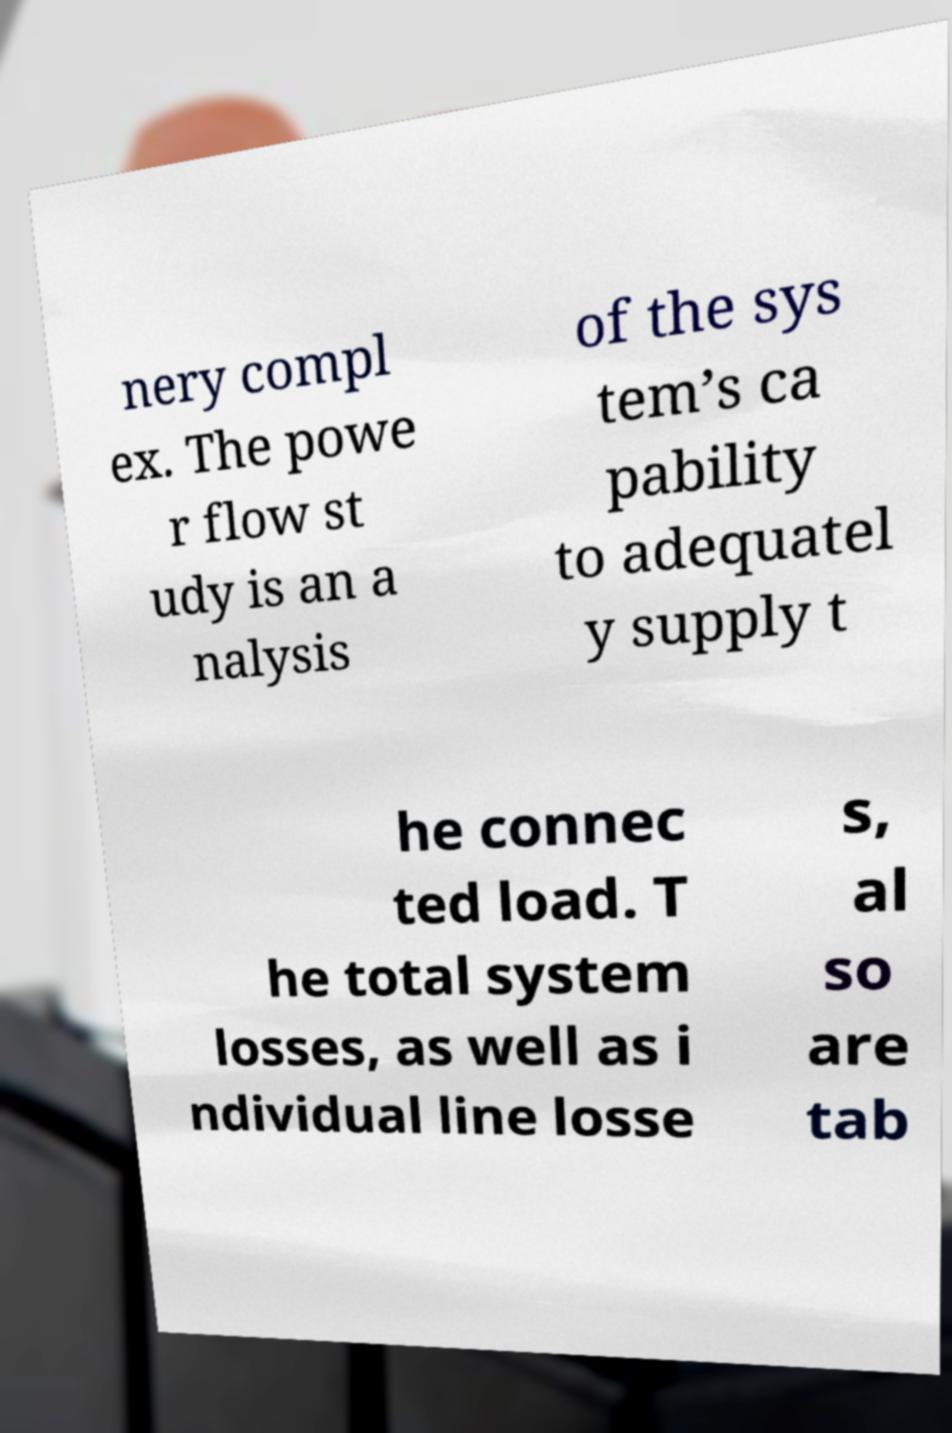Can you read and provide the text displayed in the image?This photo seems to have some interesting text. Can you extract and type it out for me? nery compl ex. The powe r flow st udy is an a nalysis of the sys tem’s ca pability to adequatel y supply t he connec ted load. T he total system losses, as well as i ndividual line losse s, al so are tab 